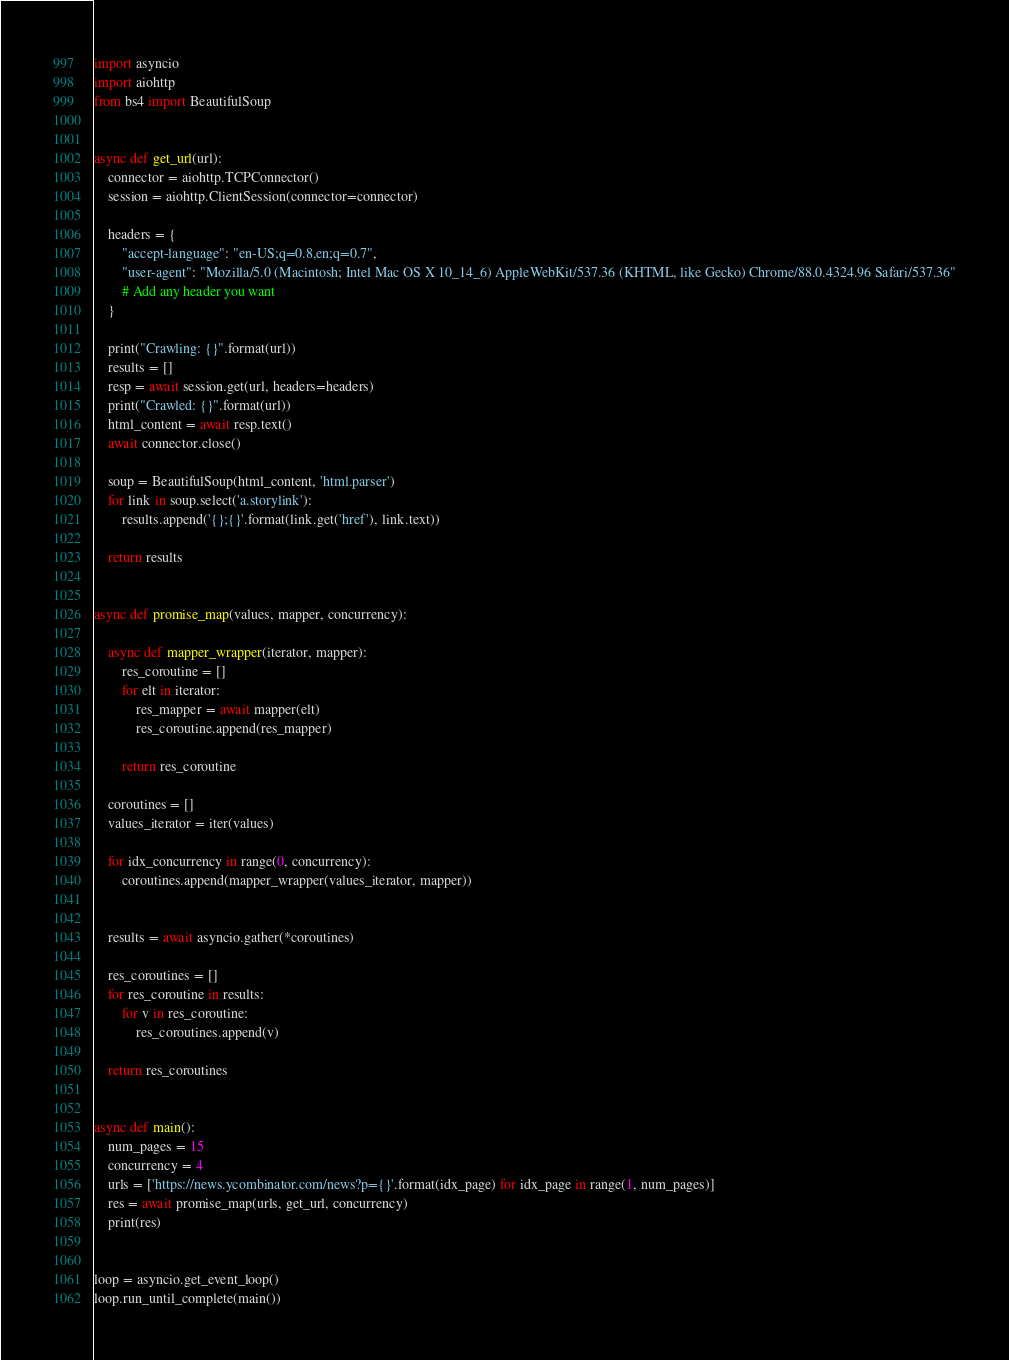<code> <loc_0><loc_0><loc_500><loc_500><_Python_>import asyncio
import aiohttp
from bs4 import BeautifulSoup


async def get_url(url):
    connector = aiohttp.TCPConnector()
    session = aiohttp.ClientSession(connector=connector)

    headers = {
        "accept-language": "en-US;q=0.8,en;q=0.7",
        "user-agent": "Mozilla/5.0 (Macintosh; Intel Mac OS X 10_14_6) AppleWebKit/537.36 (KHTML, like Gecko) Chrome/88.0.4324.96 Safari/537.36"
        # Add any header you want
    }

    print("Crawling: {}".format(url))
    results = []
    resp = await session.get(url, headers=headers)
    print("Crawled: {}".format(url))
    html_content = await resp.text()
    await connector.close()

    soup = BeautifulSoup(html_content, 'html.parser')
    for link in soup.select('a.storylink'):
        results.append('{};{}'.format(link.get('href'), link.text))

    return results


async def promise_map(values, mapper, concurrency):

    async def mapper_wrapper(iterator, mapper):
        res_coroutine = []
        for elt in iterator:
            res_mapper = await mapper(elt)
            res_coroutine.append(res_mapper)

        return res_coroutine

    coroutines = []
    values_iterator = iter(values)

    for idx_concurrency in range(0, concurrency):
        coroutines.append(mapper_wrapper(values_iterator, mapper))


    results = await asyncio.gather(*coroutines)

    res_coroutines = []
    for res_coroutine in results:
        for v in res_coroutine:
            res_coroutines.append(v)

    return res_coroutines


async def main():
    num_pages = 15
    concurrency = 4
    urls = ['https://news.ycombinator.com/news?p={}'.format(idx_page) for idx_page in range(1, num_pages)]
    res = await promise_map(urls, get_url, concurrency)
    print(res)


loop = asyncio.get_event_loop()
loop.run_until_complete(main())
</code> 